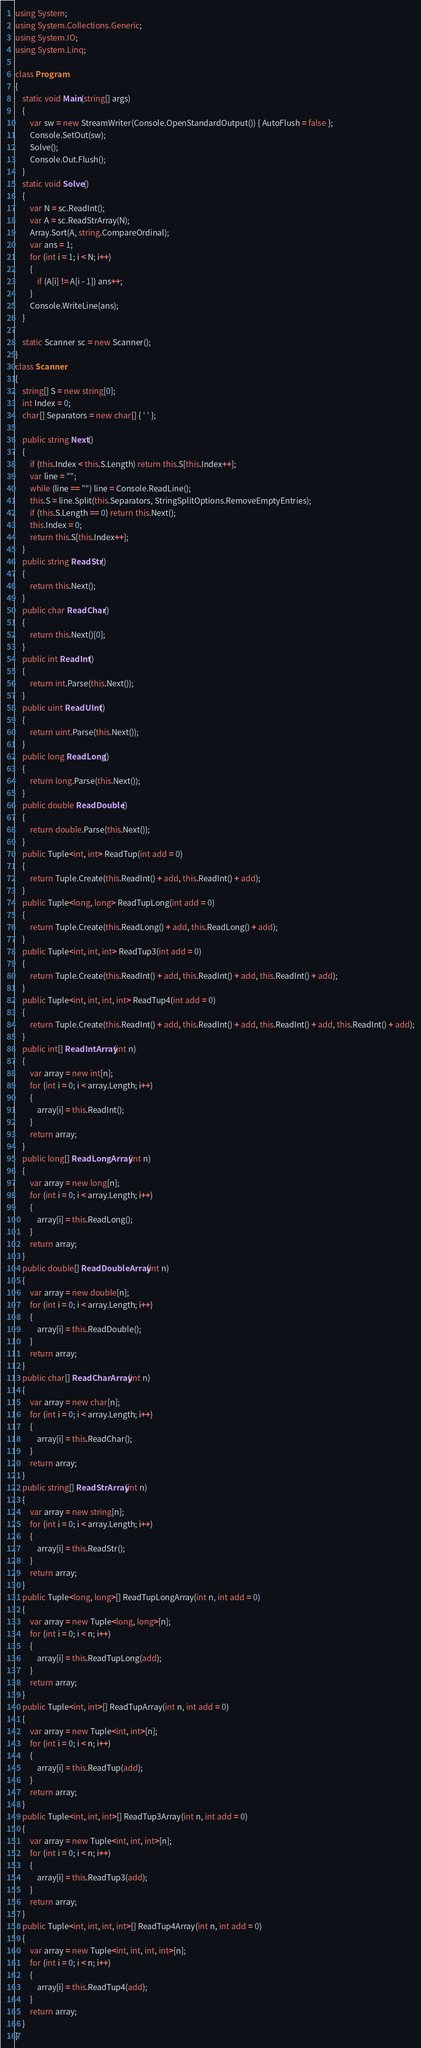<code> <loc_0><loc_0><loc_500><loc_500><_C#_>using System;
using System.Collections.Generic;
using System.IO;
using System.Linq;

class Program
{
    static void Main(string[] args)
    {
        var sw = new StreamWriter(Console.OpenStandardOutput()) { AutoFlush = false };
        Console.SetOut(sw);
        Solve();
        Console.Out.Flush();
    }
    static void Solve()
    {
        var N = sc.ReadInt();
        var A = sc.ReadStrArray(N);
        Array.Sort(A, string.CompareOrdinal);
        var ans = 1;
        for (int i = 1; i < N; i++)
        {
            if (A[i] != A[i - 1]) ans++;
        }
        Console.WriteLine(ans);
    }
    
    static Scanner sc = new Scanner();
}
class Scanner
{
    string[] S = new string[0];
    int Index = 0;
    char[] Separators = new char[] { ' ' };

    public string Next()
    {
        if (this.Index < this.S.Length) return this.S[this.Index++];
        var line = "";
        while (line == "") line = Console.ReadLine();
        this.S = line.Split(this.Separators, StringSplitOptions.RemoveEmptyEntries);
        if (this.S.Length == 0) return this.Next();
        this.Index = 0;
        return this.S[this.Index++];
    }
    public string ReadStr()
    {
        return this.Next();
    }
    public char ReadChar()
    {
        return this.Next()[0];
    }
    public int ReadInt()
    {
        return int.Parse(this.Next());
    }
    public uint ReadUInt()
    {
        return uint.Parse(this.Next());
    }
    public long ReadLong()
    {
        return long.Parse(this.Next());
    }
    public double ReadDouble()
    {
        return double.Parse(this.Next());
    }
    public Tuple<int, int> ReadTup(int add = 0)
    {
        return Tuple.Create(this.ReadInt() + add, this.ReadInt() + add);
    }
    public Tuple<long, long> ReadTupLong(int add = 0)
    {
        return Tuple.Create(this.ReadLong() + add, this.ReadLong() + add);
    }
    public Tuple<int, int, int> ReadTup3(int add = 0)
    {
        return Tuple.Create(this.ReadInt() + add, this.ReadInt() + add, this.ReadInt() + add);
    }
    public Tuple<int, int, int, int> ReadTup4(int add = 0)
    {
        return Tuple.Create(this.ReadInt() + add, this.ReadInt() + add, this.ReadInt() + add, this.ReadInt() + add);
    }
    public int[] ReadIntArray(int n)
    {
        var array = new int[n];
        for (int i = 0; i < array.Length; i++)
        {
            array[i] = this.ReadInt();
        }
        return array;
    }
    public long[] ReadLongArray(int n)
    {
        var array = new long[n];
        for (int i = 0; i < array.Length; i++)
        {
            array[i] = this.ReadLong();
        }
        return array;
    }
    public double[] ReadDoubleArray(int n)
    {
        var array = new double[n];
        for (int i = 0; i < array.Length; i++)
        {
            array[i] = this.ReadDouble();
        }
        return array;
    }
    public char[] ReadCharArray(int n)
    {
        var array = new char[n];
        for (int i = 0; i < array.Length; i++)
        {
            array[i] = this.ReadChar();
        }
        return array;
    }
    public string[] ReadStrArray(int n)
    {
        var array = new string[n];
        for (int i = 0; i < array.Length; i++)
        {
            array[i] = this.ReadStr();
        }
        return array;
    }
    public Tuple<long, long>[] ReadTupLongArray(int n, int add = 0)
    {
        var array = new Tuple<long, long>[n];
        for (int i = 0; i < n; i++)
        {
            array[i] = this.ReadTupLong(add);
        }
        return array;
    }
    public Tuple<int, int>[] ReadTupArray(int n, int add = 0)
    {
        var array = new Tuple<int, int>[n];
        for (int i = 0; i < n; i++)
        {
            array[i] = this.ReadTup(add);
        }
        return array;
    }
    public Tuple<int, int, int>[] ReadTup3Array(int n, int add = 0)
    {
        var array = new Tuple<int, int, int>[n];
        for (int i = 0; i < n; i++)
        {
            array[i] = this.ReadTup3(add);
        }
        return array;
    }
    public Tuple<int, int, int, int>[] ReadTup4Array(int n, int add = 0)
    {
        var array = new Tuple<int, int, int, int>[n];
        for (int i = 0; i < n; i++)
        {
            array[i] = this.ReadTup4(add);
        }
        return array;
    }
}
</code> 